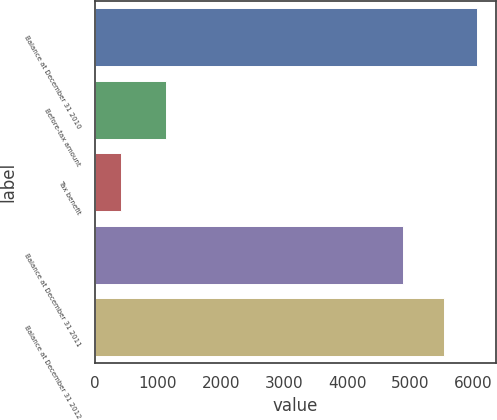<chart> <loc_0><loc_0><loc_500><loc_500><bar_chart><fcel>Balance at December 31 2010<fcel>Before-tax amount<fcel>Tax benefit<fcel>Balance at December 31 2011<fcel>Balance at December 31 2012<nl><fcel>6052<fcel>1125<fcel>417<fcel>4879<fcel>5535<nl></chart> 